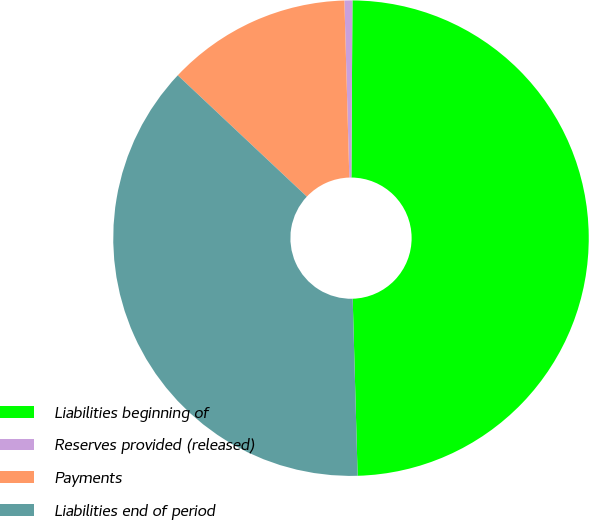<chart> <loc_0><loc_0><loc_500><loc_500><pie_chart><fcel>Liabilities beginning of<fcel>Reserves provided (released)<fcel>Payments<fcel>Liabilities end of period<nl><fcel>49.46%<fcel>0.54%<fcel>12.55%<fcel>37.45%<nl></chart> 